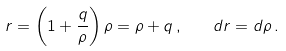Convert formula to latex. <formula><loc_0><loc_0><loc_500><loc_500>r = \left ( 1 + \frac { q } { \rho } \right ) \rho = \rho + q \, , \quad d r = d \rho \, .</formula> 